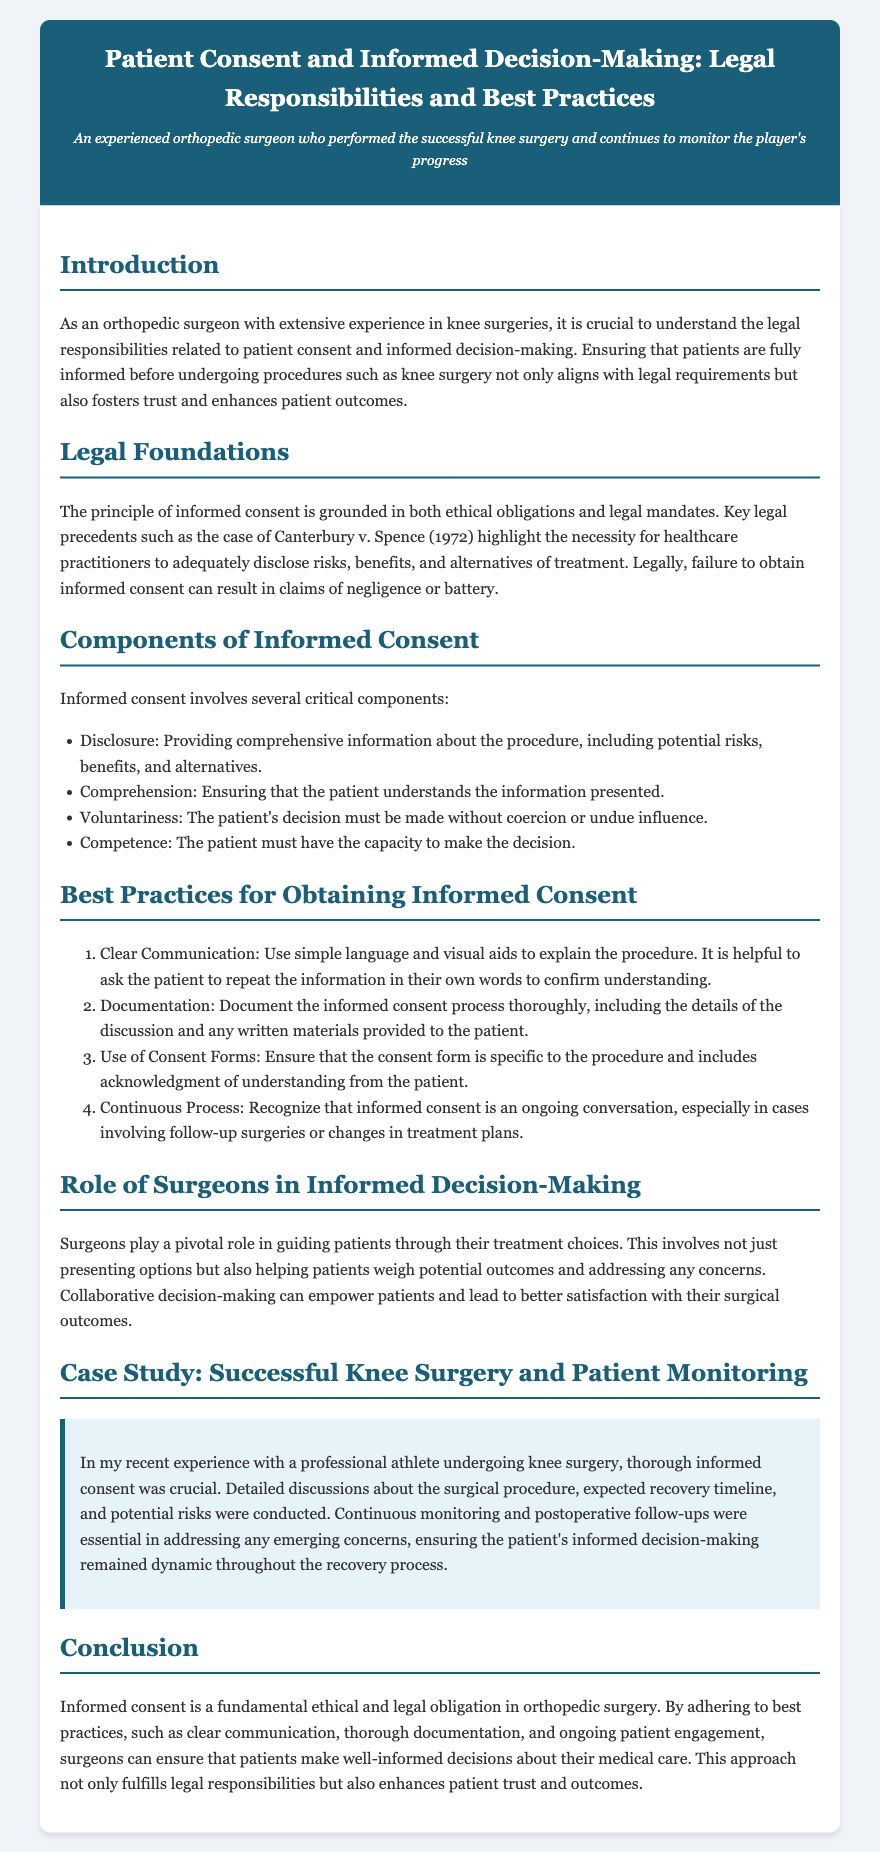what is the main topic of the legal brief? The main topic is about patient consent and informed decision-making in healthcare.
Answer: Patient Consent and Informed Decision-Making which legal case is referenced in relation to informed consent? The document mentions a key legal precedent related to informed consent.
Answer: Canterbury v. Spence how many components of informed consent are listed? The document outlines the critical components of informed consent.
Answer: Four what is one of the best practices for obtaining informed consent? The document provides a list of best practices for obtaining informed consent in healthcare.
Answer: Clear Communication who plays a pivotal role in the informed decision-making process? The document highlights the role of healthcare professionals in guiding patients.
Answer: Surgeons what should documentation of the informed consent process include? The document specifies what needs to be documented during the informed consent process.
Answer: Details of the discussion how does the case study emphasize the importance of informed consent? The case study illustrates how informed consent affects patient outcomes and monitoring.
Answer: Thorough discussions what is the concluding statement's view on informed consent? The conclusion summarizes the importance of informed consent in medical ethics and law.
Answer: A fundamental ethical and legal obligation 